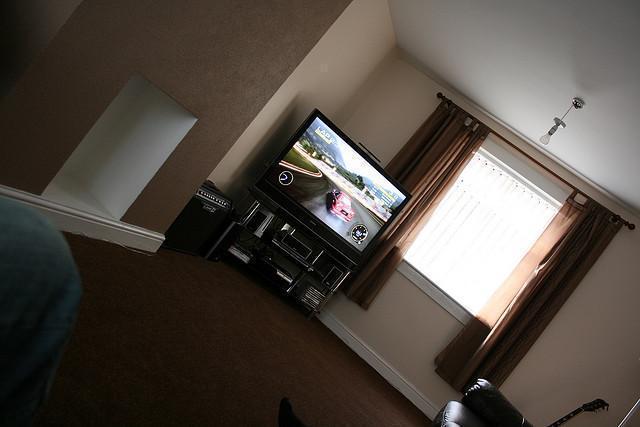What type of game is being played?
From the following set of four choices, select the accurate answer to respond to the question.
Options: Card, athletic, board, video. Video. 